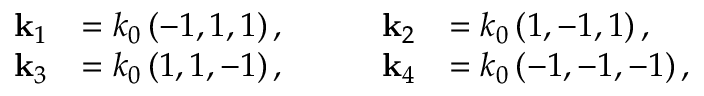Convert formula to latex. <formula><loc_0><loc_0><loc_500><loc_500>\begin{array} { r l } { k _ { 1 } } & { = k _ { 0 } \left ( - 1 , 1 , 1 \right ) , } \\ { k _ { 3 } } & { = k _ { 0 } \left ( 1 , 1 , - 1 \right ) , } \end{array} \quad \begin{array} { r l } { k _ { 2 } } & { = k _ { 0 } \left ( 1 , - 1 , 1 \right ) , } \\ { k _ { 4 } } & { = k _ { 0 } \left ( - 1 , - 1 , - 1 \right ) , } \end{array}</formula> 